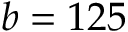<formula> <loc_0><loc_0><loc_500><loc_500>b = 1 2 5</formula> 